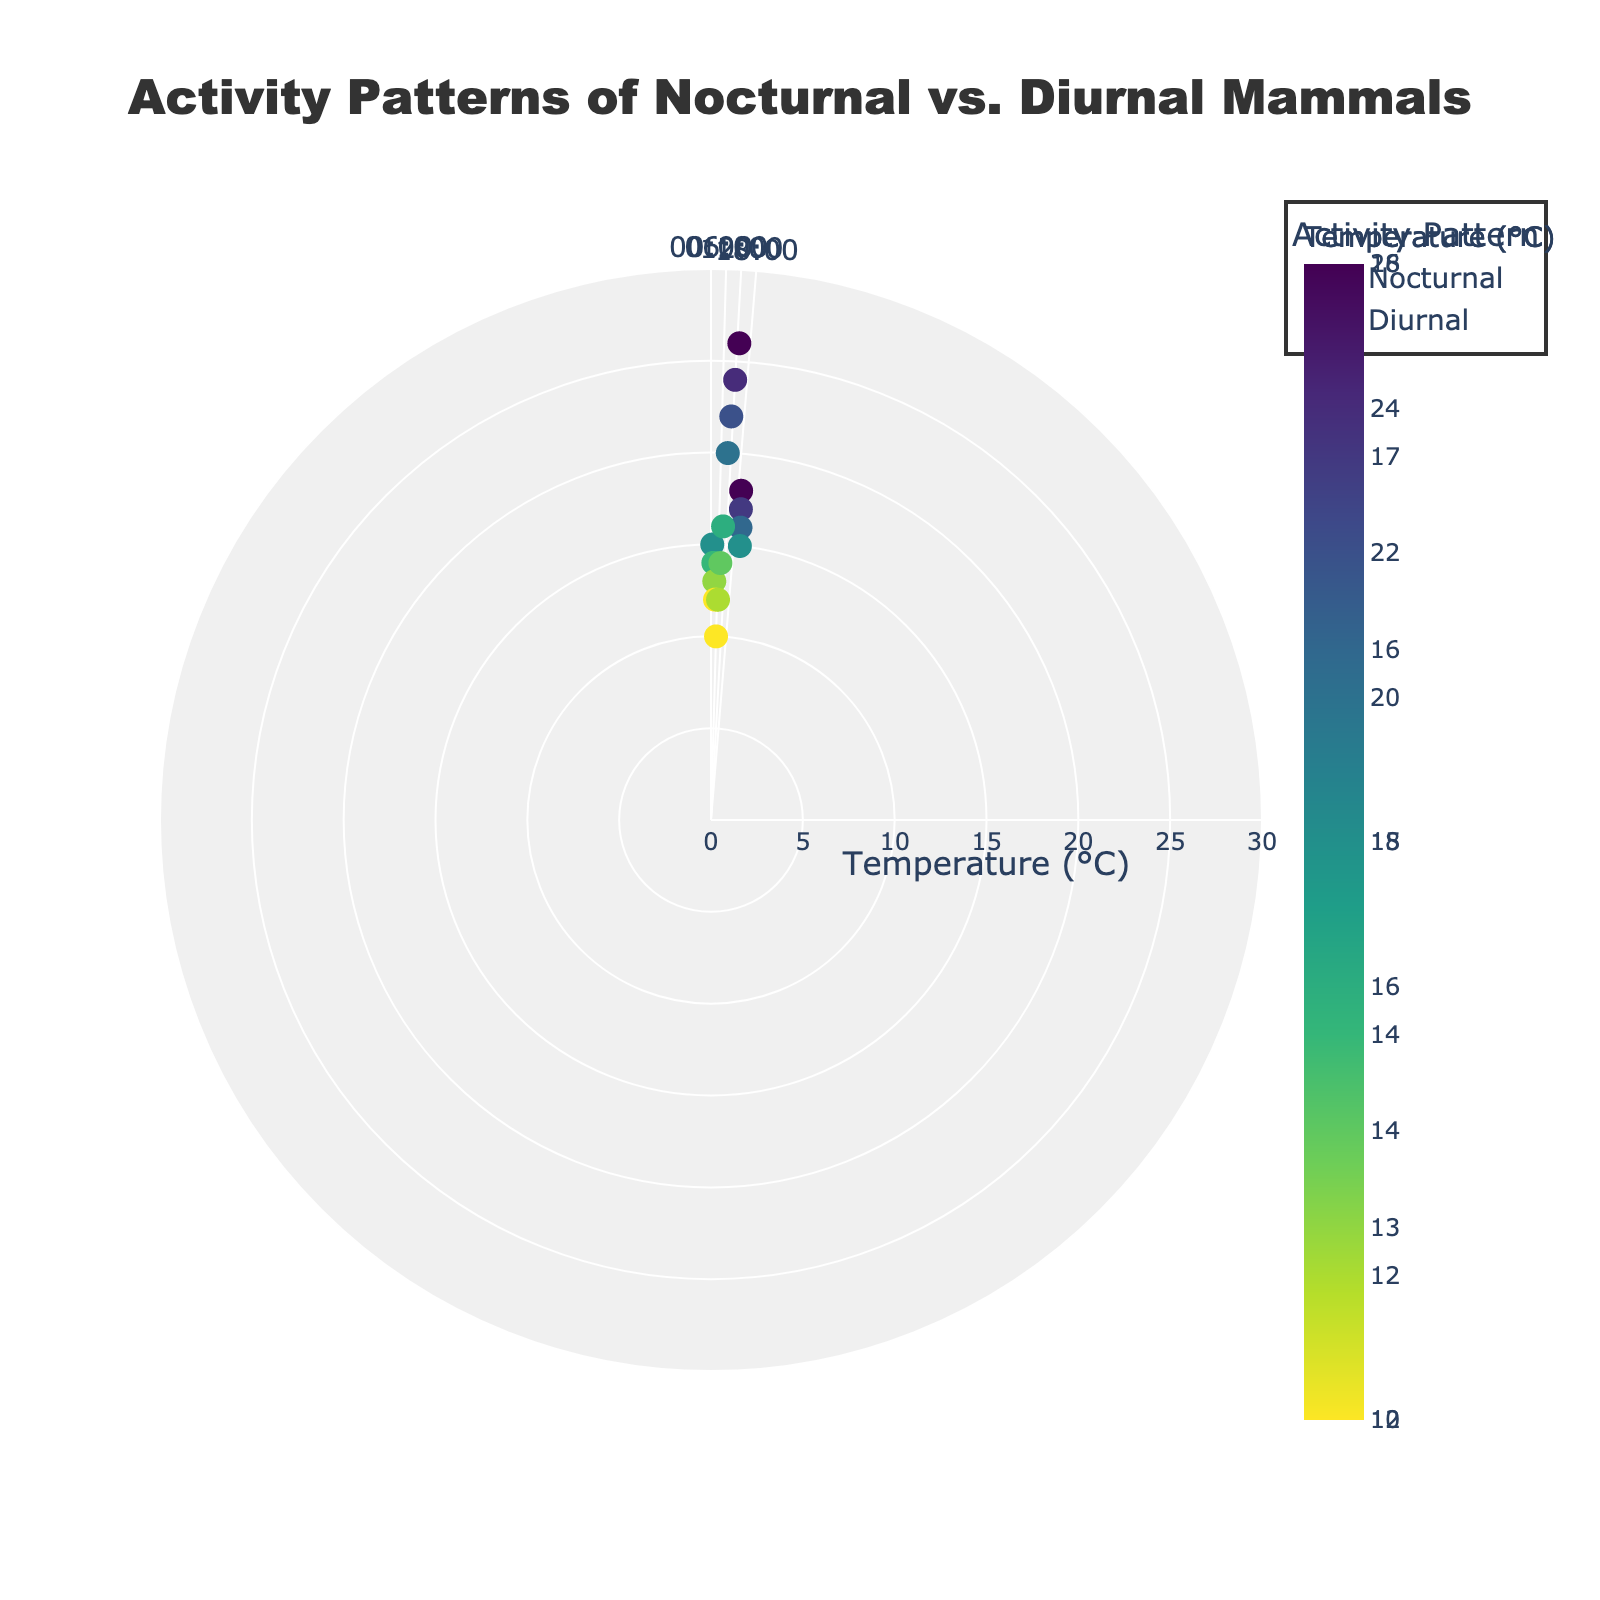How many diurnal animals were observed to be active? There are two diurnal animals (Deer and Squirrel). The Deer was observed to be active at 6:00 and 7:00. The Squirrel was observed to be active at 10:00 and 11:00. Adding these up, we get 2 + 2 = 4
Answer: 4 Which mammal was observed to be resting at the lowest temperature? By checking the temperature when each animal was observed to be resting, the FieldMouse was resting at 12°C, 13°C, and the Bat at 15°C. The lowest temperature is 12°C.
Answer: FieldMouse At what hours were FieldMouse and Bat both observed to be active? The FieldMouse was active at 1:00 and 2:00, and the Bat was active at 20:00 and 21:00. There is no overlap, implying they were not both active at the same hours.
Answer: None Compare the temperature range in which the diurnal Squirrel and nocturnal Bat were active. Which animal is active in a wider range of temperatures? Temperatures for Squirrel: 20°C and 22°C (range: 22 - 20 = 2°C). Temperatures for Bat: 17°C and 18°C (range: 18 - 17 = 1°C). The Squirrel has a wider temperature range.
Answer: Squirrel What is the average temperature when nocturnal animals are resting? Nocturnal animals resting temperatures: 13°C (FieldMouse), 12°C (FieldMouse), 16°C (Bat), and 15°C (Bat). The average is (13 + 12 + 16 + 15) / 4 = 56 / 4 = 14°C.
Answer: 14°C Which activity pattern has a broader time distribution, nocturnal or diurnal? Nocturnal FieldMouse: 1:00-4:00, Bat: 20:00-23:00 (total hours: 7). Diurnal Deer: 6:00-9:00, Squirrel: 10:00-13:00 (total hours: 8). Diurnal has a broader time distribution.
Answer: Diurnal What is the maximum temperature observed during the resting observation periods for all animals? For FieldMouse: 13°C and 12°C, for Bat: 16°C and 15°C, for Deer: 14°C and 16°C, for Squirrel: 24°C and 26°C. The maximum temperature observed is 26°C.
Answer: 26°C 